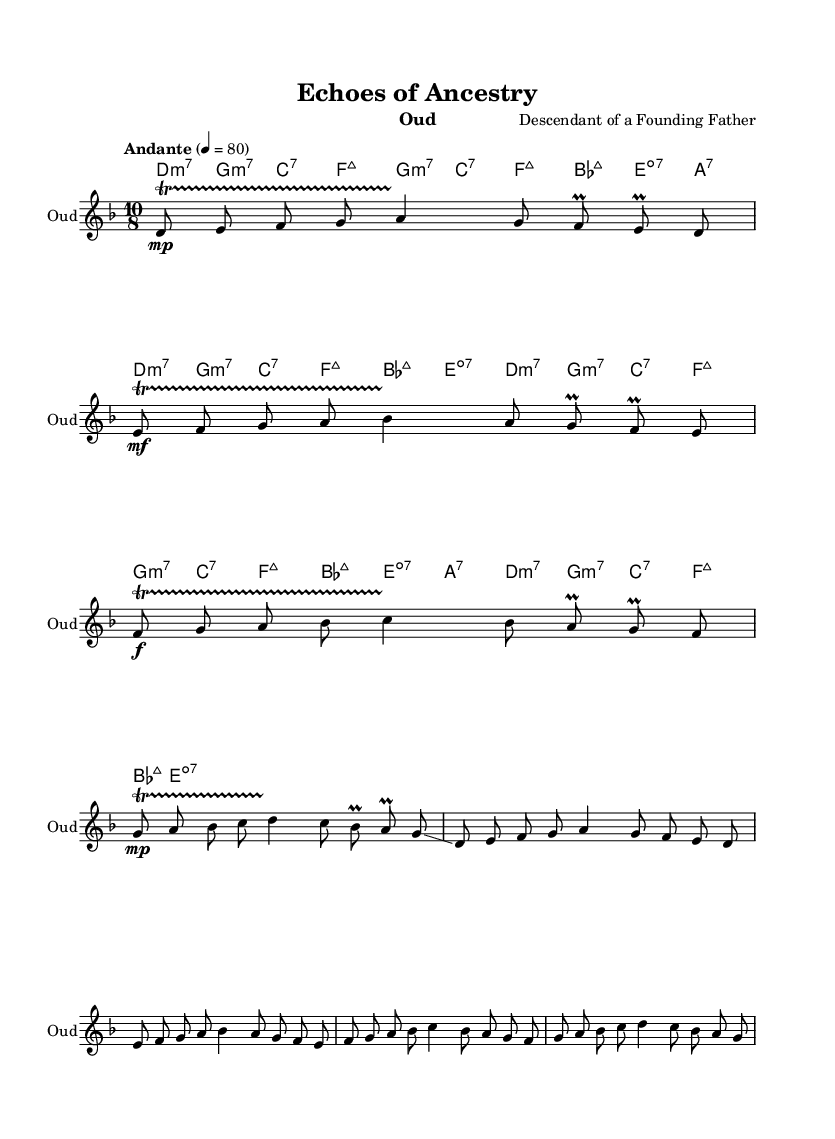What is the key signature of this music? The key signature is D minor, indicated by the presence of a B flat. This can be seen at the beginning of the sheet music, which displays one flat in the key signature.
Answer: D minor What is the time signature of this piece? The time signature is 10/8, noted at the beginning of the score. It indicates that there are ten eighth notes per measure, which shapes the rhythmic feel of the composition.
Answer: 10/8 What is the tempo marking of the music? The tempo marking is Andante, which can be seen written as "Andante" with the metronome marking of 4 = 80. This suggests a moderate pace for the piece.
Answer: Andante What is the dynamics indication in the introduction? The introduction features a variety of dynamics, notably starting with a mezzo-piano (mp) dynamic for the first measure. This is indicated by the symbol next to the first note.
Answer: mezzo-piano How many primary sections can be identified in the melody? The melody can be divided into three primary sections: introduction, verse, and chorus. Each section has distinct melodic content and pacing, which can be identified through the layout of measures.
Answer: Three What type of music is reflected in this composition? This composition reflects Middle Eastern music, as it prominently features the oud as the instrument and utilizes traditional modes and rhythms characteristic of the region's musical style.
Answer: Middle Eastern What is the chord progression for the chorus? The chord progression for the chorus includes F, G, A, B flat, C, B flat, A, and G in the harmonies section, providing a framework for the melodies sung or played during this section.
Answer: F, G, A, B flat, C, B flat, A, G 